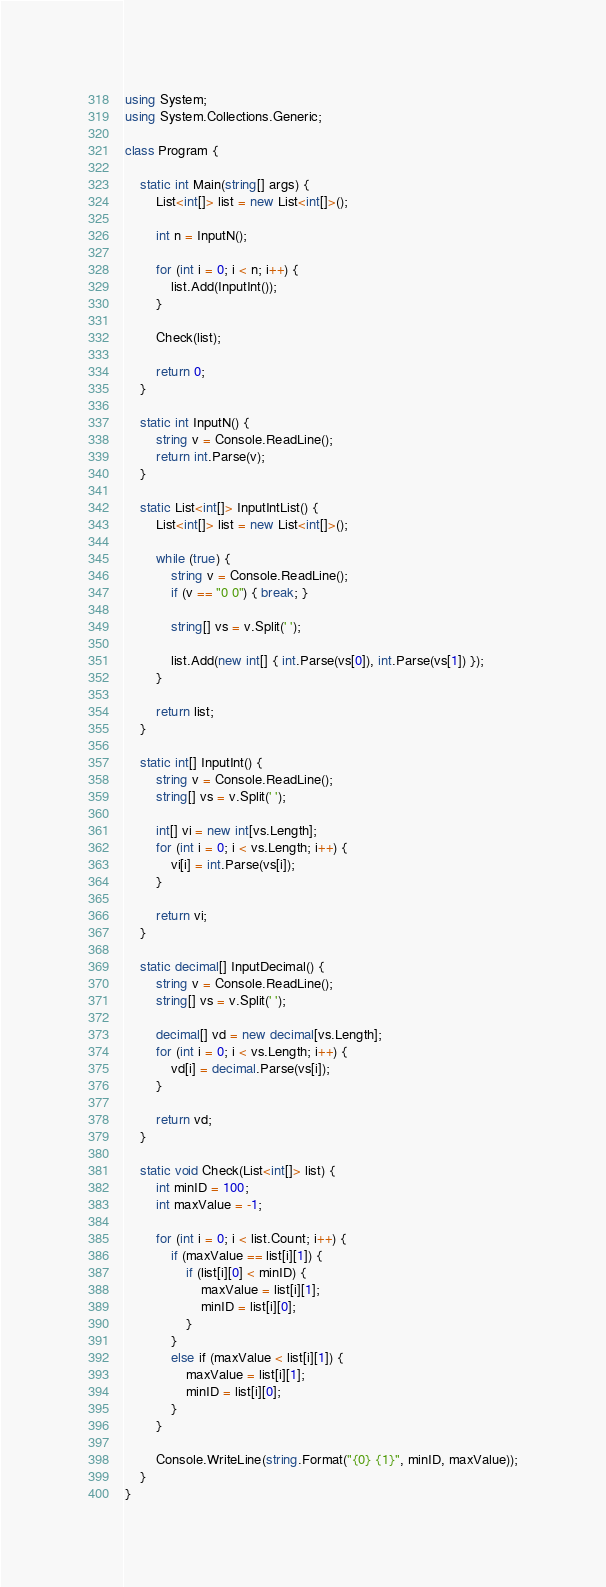Convert code to text. <code><loc_0><loc_0><loc_500><loc_500><_C#_>using System;
using System.Collections.Generic;

class Program {

    static int Main(string[] args) {
        List<int[]> list = new List<int[]>();

        int n = InputN();

        for (int i = 0; i < n; i++) {
            list.Add(InputInt());
        }

        Check(list);

        return 0;
    }

    static int InputN() {
        string v = Console.ReadLine();
        return int.Parse(v);
    }

    static List<int[]> InputIntList() {
        List<int[]> list = new List<int[]>();

        while (true) {
            string v = Console.ReadLine();
            if (v == "0 0") { break; }

            string[] vs = v.Split(' ');

            list.Add(new int[] { int.Parse(vs[0]), int.Parse(vs[1]) });
        }

        return list;
    }

    static int[] InputInt() {
        string v = Console.ReadLine();
        string[] vs = v.Split(' ');

        int[] vi = new int[vs.Length];
        for (int i = 0; i < vs.Length; i++) {
            vi[i] = int.Parse(vs[i]);
        }

        return vi;
    }

    static decimal[] InputDecimal() {
        string v = Console.ReadLine();
        string[] vs = v.Split(' ');

        decimal[] vd = new decimal[vs.Length];
        for (int i = 0; i < vs.Length; i++) {
            vd[i] = decimal.Parse(vs[i]);
        }

        return vd;
    }

    static void Check(List<int[]> list) {
        int minID = 100;
        int maxValue = -1;

        for (int i = 0; i < list.Count; i++) {
            if (maxValue == list[i][1]) {
                if (list[i][0] < minID) {
                    maxValue = list[i][1];
                    minID = list[i][0];
                }
            }
            else if (maxValue < list[i][1]) {
                maxValue = list[i][1];
                minID = list[i][0];
            }
        }

        Console.WriteLine(string.Format("{0} {1}", minID, maxValue));
    }
}</code> 